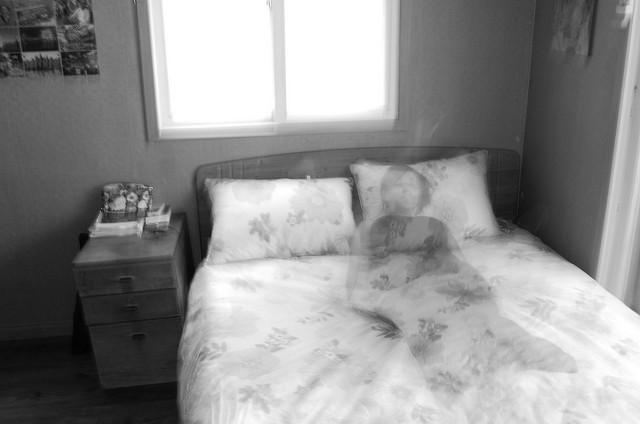How many birds are in the background?
Give a very brief answer. 0. 